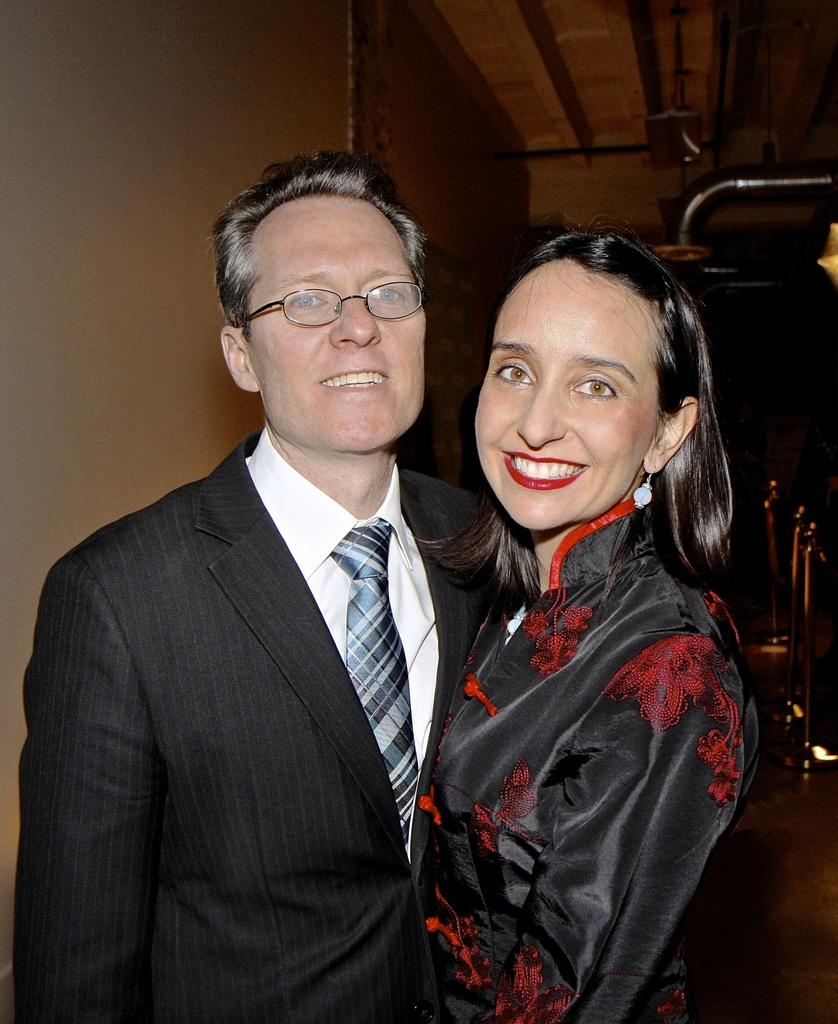What is the gender of the person in the image? There is a man in the image. Can you describe the man's appearance? The man is wearing glasses (specs). Who else is present in the image? There is a woman in the image. How are the man and woman depicted in the image? Both the man and woman are smiling. What can be seen in the background of the image? There are small poles and a wall in the background of the image. What type of metal is the mountain made of in the image? There is no mountain present in the image, and therefore no metal can be associated with it. 